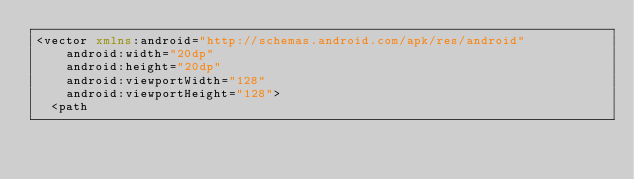<code> <loc_0><loc_0><loc_500><loc_500><_XML_><vector xmlns:android="http://schemas.android.com/apk/res/android"
    android:width="20dp"
    android:height="20dp"
    android:viewportWidth="128"
    android:viewportHeight="128">
  <path</code> 